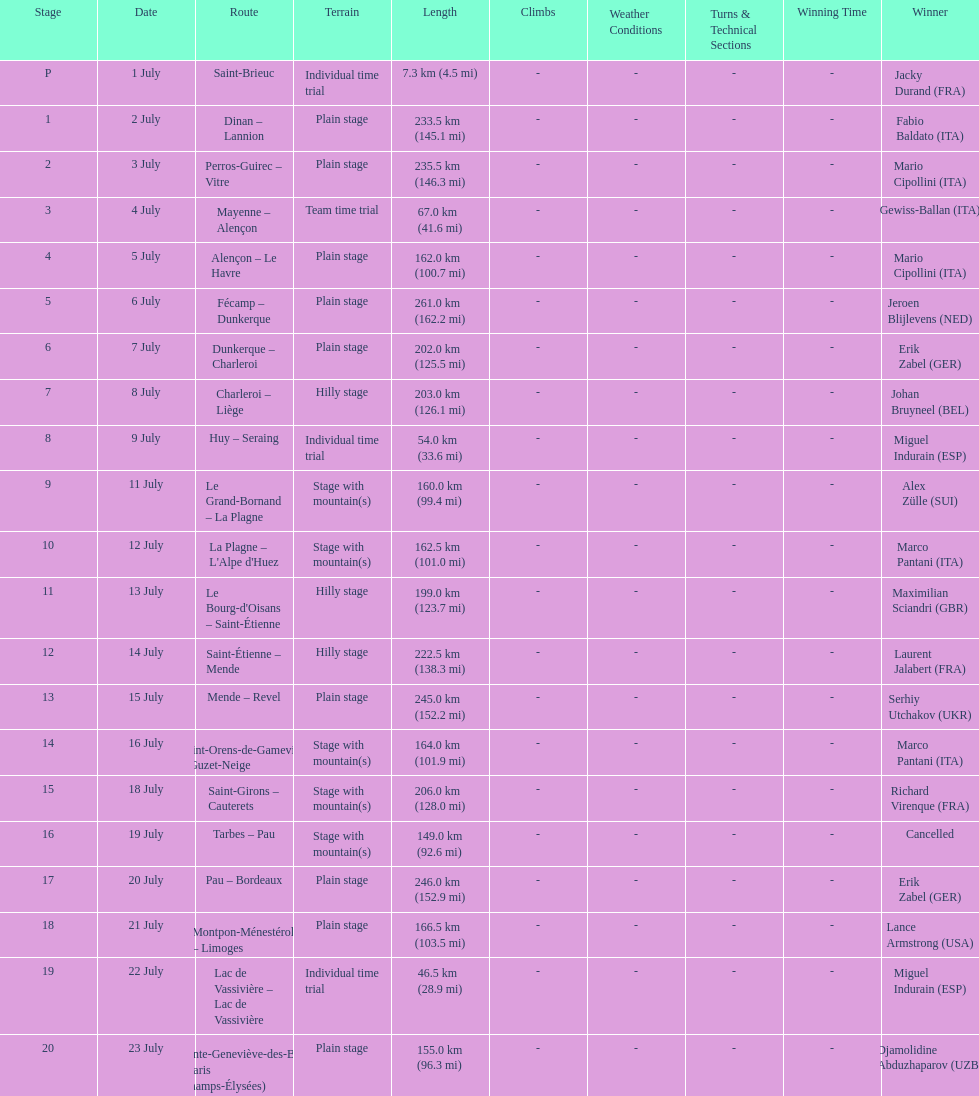Which country had more stage-winners than any other country? Italy. Would you mind parsing the complete table? {'header': ['Stage', 'Date', 'Route', 'Terrain', 'Length', 'Climbs', 'Weather Conditions', 'Turns & Technical Sections', 'Winning Time', 'Winner'], 'rows': [['P', '1 July', 'Saint-Brieuc', 'Individual time trial', '7.3\xa0km (4.5\xa0mi)', '-', '-', '-', '-', 'Jacky Durand\xa0(FRA)'], ['1', '2 July', 'Dinan – Lannion', 'Plain stage', '233.5\xa0km (145.1\xa0mi)', '-', '-', '-', '-', 'Fabio Baldato\xa0(ITA)'], ['2', '3 July', 'Perros-Guirec – Vitre', 'Plain stage', '235.5\xa0km (146.3\xa0mi)', '-', '-', '-', '-', 'Mario Cipollini\xa0(ITA)'], ['3', '4 July', 'Mayenne – Alençon', 'Team time trial', '67.0\xa0km (41.6\xa0mi)', '-', '-', '-', '-', 'Gewiss-Ballan\xa0(ITA)'], ['4', '5 July', 'Alençon – Le Havre', 'Plain stage', '162.0\xa0km (100.7\xa0mi)', '-', '-', '-', '-', 'Mario Cipollini\xa0(ITA)'], ['5', '6 July', 'Fécamp – Dunkerque', 'Plain stage', '261.0\xa0km (162.2\xa0mi)', '-', '-', '-', '-', 'Jeroen Blijlevens\xa0(NED)'], ['6', '7 July', 'Dunkerque – Charleroi', 'Plain stage', '202.0\xa0km (125.5\xa0mi)', '-', '-', '-', '-', 'Erik Zabel\xa0(GER)'], ['7', '8 July', 'Charleroi – Liège', 'Hilly stage', '203.0\xa0km (126.1\xa0mi)', '-', '-', '-', '-', 'Johan Bruyneel\xa0(BEL)'], ['8', '9 July', 'Huy – Seraing', 'Individual time trial', '54.0\xa0km (33.6\xa0mi)', '-', '-', '-', '-', 'Miguel Indurain\xa0(ESP)'], ['9', '11 July', 'Le Grand-Bornand – La Plagne', 'Stage with mountain(s)', '160.0\xa0km (99.4\xa0mi)', '-', '-', '-', '-', 'Alex Zülle\xa0(SUI)'], ['10', '12 July', "La Plagne – L'Alpe d'Huez", 'Stage with mountain(s)', '162.5\xa0km (101.0\xa0mi)', '-', '-', '-', '-', 'Marco Pantani\xa0(ITA)'], ['11', '13 July', "Le Bourg-d'Oisans – Saint-Étienne", 'Hilly stage', '199.0\xa0km (123.7\xa0mi)', '-', '-', '-', '-', 'Maximilian Sciandri\xa0(GBR)'], ['12', '14 July', 'Saint-Étienne – Mende', 'Hilly stage', '222.5\xa0km (138.3\xa0mi)', '-', '-', '-', '-', 'Laurent Jalabert\xa0(FRA)'], ['13', '15 July', 'Mende – Revel', 'Plain stage', '245.0\xa0km (152.2\xa0mi)', '-', '-', '-', '-', 'Serhiy Utchakov\xa0(UKR)'], ['14', '16 July', 'Saint-Orens-de-Gameville – Guzet-Neige', 'Stage with mountain(s)', '164.0\xa0km (101.9\xa0mi)', '-', '-', '-', '-', 'Marco Pantani\xa0(ITA)'], ['15', '18 July', 'Saint-Girons – Cauterets', 'Stage with mountain(s)', '206.0\xa0km (128.0\xa0mi)', '-', '-', '-', '-', 'Richard Virenque\xa0(FRA)'], ['16', '19 July', 'Tarbes – Pau', 'Stage with mountain(s)', '149.0\xa0km (92.6\xa0mi)', '-', '-', '-', '-', 'Cancelled'], ['17', '20 July', 'Pau – Bordeaux', 'Plain stage', '246.0\xa0km (152.9\xa0mi)', '-', '-', '-', '-', 'Erik Zabel\xa0(GER)'], ['18', '21 July', 'Montpon-Ménestérol – Limoges', 'Plain stage', '166.5\xa0km (103.5\xa0mi)', '-', '-', '-', '-', 'Lance Armstrong\xa0(USA)'], ['19', '22 July', 'Lac de Vassivière – Lac de Vassivière', 'Individual time trial', '46.5\xa0km (28.9\xa0mi)', '-', '-', '-', '-', 'Miguel Indurain\xa0(ESP)'], ['20', '23 July', 'Sainte-Geneviève-des-Bois – Paris (Champs-Élysées)', 'Plain stage', '155.0\xa0km (96.3\xa0mi)', '-', '-', '-', '-', 'Djamolidine Abduzhaparov\xa0(UZB)']]} 